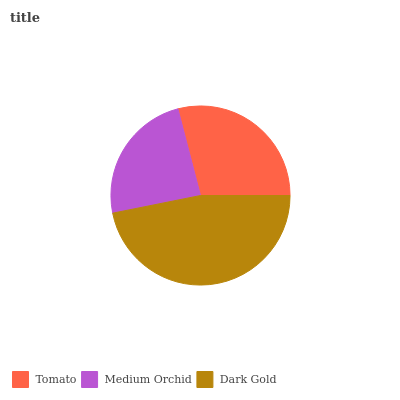Is Medium Orchid the minimum?
Answer yes or no. Yes. Is Dark Gold the maximum?
Answer yes or no. Yes. Is Dark Gold the minimum?
Answer yes or no. No. Is Medium Orchid the maximum?
Answer yes or no. No. Is Dark Gold greater than Medium Orchid?
Answer yes or no. Yes. Is Medium Orchid less than Dark Gold?
Answer yes or no. Yes. Is Medium Orchid greater than Dark Gold?
Answer yes or no. No. Is Dark Gold less than Medium Orchid?
Answer yes or no. No. Is Tomato the high median?
Answer yes or no. Yes. Is Tomato the low median?
Answer yes or no. Yes. Is Medium Orchid the high median?
Answer yes or no. No. Is Medium Orchid the low median?
Answer yes or no. No. 